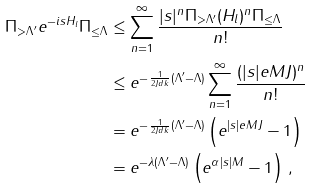Convert formula to latex. <formula><loc_0><loc_0><loc_500><loc_500>\| \Pi _ { > \Lambda ^ { \prime } } e ^ { - i s H _ { l } } \Pi _ { \leq \Lambda } \| & \leq \sum _ { n = 1 } ^ { \infty } \frac { | s | ^ { n } \| \Pi _ { > \Lambda ^ { \prime } } ( H _ { l } ) ^ { n } \Pi _ { \leq \Lambda } \| } { n ! } \\ & \leq e ^ { - \frac { 1 } { 2 J d k } ( \Lambda ^ { \prime } - \Lambda ) } \sum _ { n = 1 } ^ { \infty } \frac { ( | s | e M J ) ^ { n } } { n ! } \\ & = e ^ { - \frac { 1 } { 2 J d k } ( \Lambda ^ { \prime } - \Lambda ) } \left ( e ^ { | s | e M J } - 1 \right ) \\ & = e ^ { - \lambda ( \Lambda ^ { \prime } - \Lambda ) } \left ( e ^ { \alpha | s | M } - 1 \right ) \, ,</formula> 